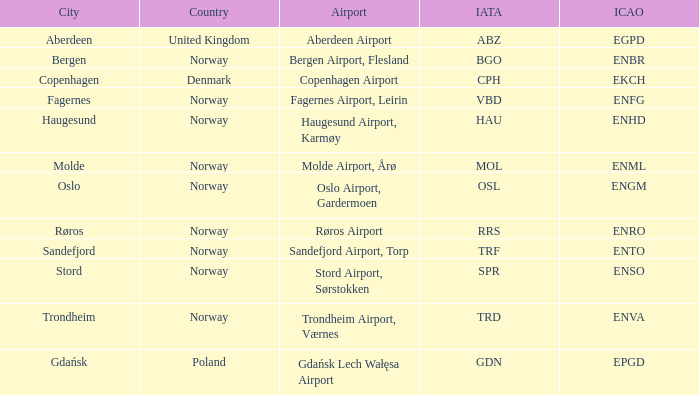What Country has a ICAO of EKCH? Denmark. 